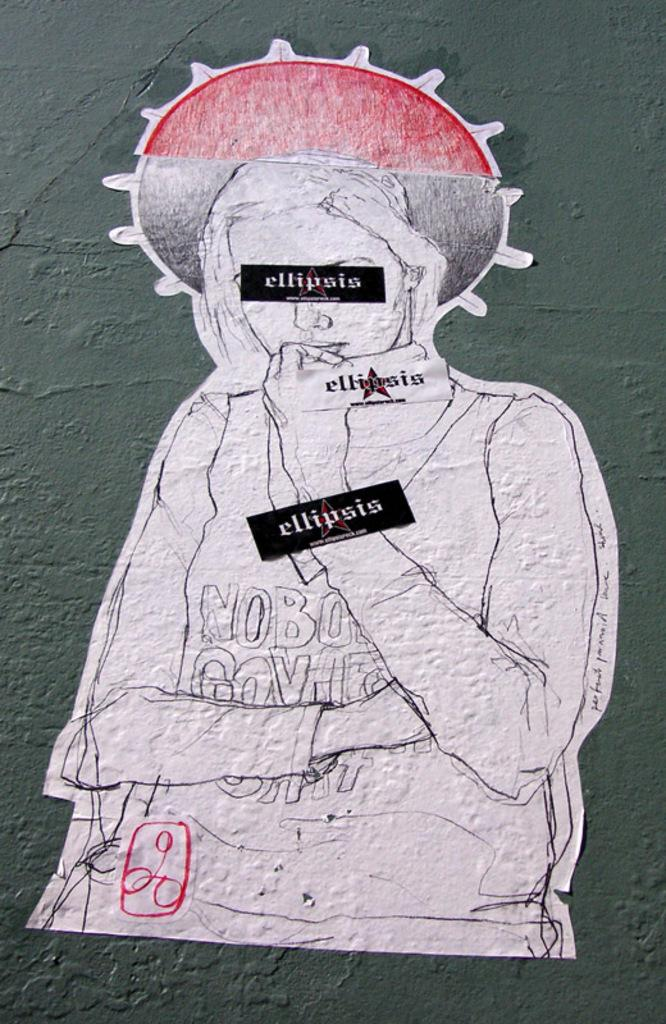What is the main subject of the painting in the image? The main subject of the painting in the image is a woman. Are there any additional elements on the painting besides the woman? Yes, there are texts on the painting. What is the color of the background in the image? The background of the image is gray in color. How many lips can be seen on the painting in the image? There are no lips visible on the painting in the image; it features a woman and texts. Is there a crib present in the image? There is no crib present in the image; it contains a painting of a woman with texts and has a gray background. 